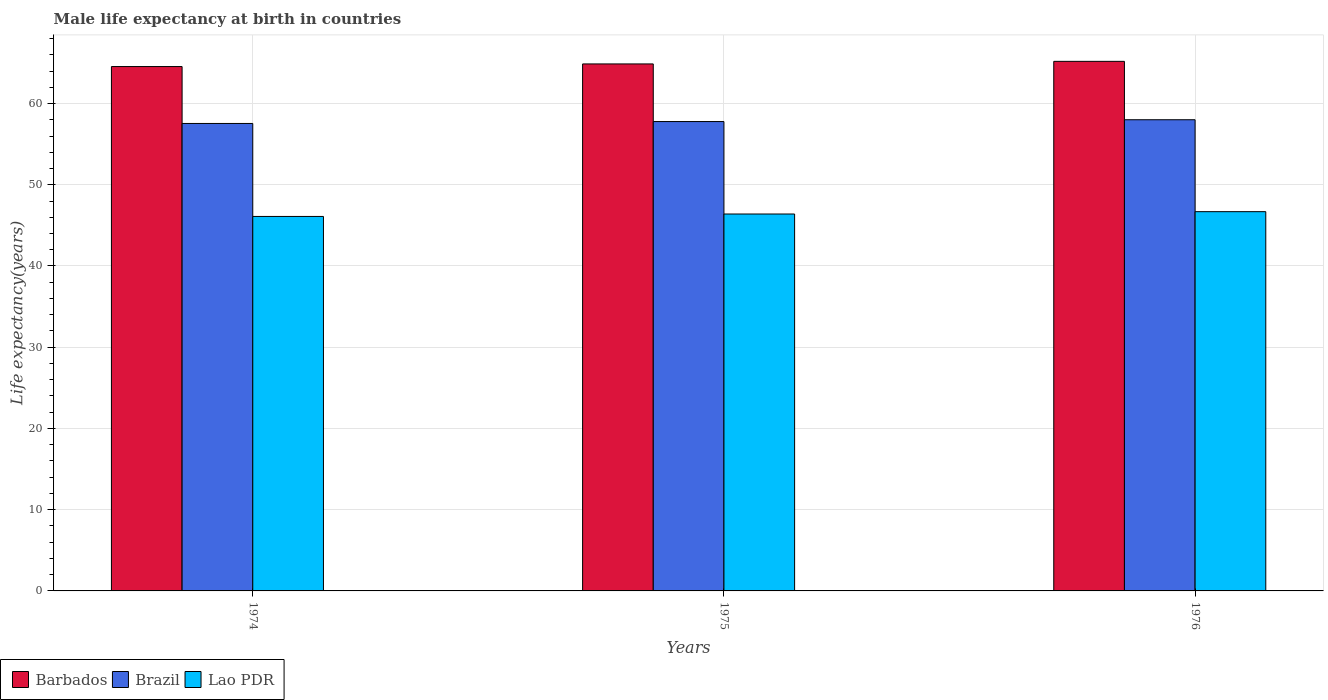How many different coloured bars are there?
Your answer should be compact. 3. How many groups of bars are there?
Make the answer very short. 3. Are the number of bars per tick equal to the number of legend labels?
Provide a short and direct response. Yes. Are the number of bars on each tick of the X-axis equal?
Offer a terse response. Yes. How many bars are there on the 2nd tick from the left?
Provide a short and direct response. 3. What is the label of the 1st group of bars from the left?
Offer a very short reply. 1974. In how many cases, is the number of bars for a given year not equal to the number of legend labels?
Keep it short and to the point. 0. What is the male life expectancy at birth in Barbados in 1974?
Keep it short and to the point. 64.55. Across all years, what is the maximum male life expectancy at birth in Brazil?
Give a very brief answer. 58. Across all years, what is the minimum male life expectancy at birth in Barbados?
Offer a very short reply. 64.55. In which year was the male life expectancy at birth in Lao PDR maximum?
Provide a succinct answer. 1976. In which year was the male life expectancy at birth in Lao PDR minimum?
Offer a terse response. 1974. What is the total male life expectancy at birth in Brazil in the graph?
Provide a short and direct response. 173.33. What is the difference between the male life expectancy at birth in Lao PDR in 1975 and that in 1976?
Offer a terse response. -0.29. What is the difference between the male life expectancy at birth in Brazil in 1975 and the male life expectancy at birth in Lao PDR in 1976?
Ensure brevity in your answer.  11.09. What is the average male life expectancy at birth in Lao PDR per year?
Provide a succinct answer. 46.4. In the year 1976, what is the difference between the male life expectancy at birth in Lao PDR and male life expectancy at birth in Barbados?
Keep it short and to the point. -18.5. What is the ratio of the male life expectancy at birth in Lao PDR in 1974 to that in 1976?
Your answer should be very brief. 0.99. Is the male life expectancy at birth in Brazil in 1975 less than that in 1976?
Provide a short and direct response. Yes. What is the difference between the highest and the second highest male life expectancy at birth in Lao PDR?
Your answer should be very brief. 0.29. What is the difference between the highest and the lowest male life expectancy at birth in Barbados?
Your answer should be compact. 0.64. What does the 1st bar from the left in 1975 represents?
Offer a terse response. Barbados. What does the 2nd bar from the right in 1975 represents?
Ensure brevity in your answer.  Brazil. How many bars are there?
Your answer should be compact. 9. Are all the bars in the graph horizontal?
Provide a succinct answer. No. How many years are there in the graph?
Your response must be concise. 3. Are the values on the major ticks of Y-axis written in scientific E-notation?
Provide a short and direct response. No. Does the graph contain any zero values?
Make the answer very short. No. Does the graph contain grids?
Ensure brevity in your answer.  Yes. How many legend labels are there?
Give a very brief answer. 3. What is the title of the graph?
Provide a short and direct response. Male life expectancy at birth in countries. What is the label or title of the Y-axis?
Ensure brevity in your answer.  Life expectancy(years). What is the Life expectancy(years) of Barbados in 1974?
Make the answer very short. 64.55. What is the Life expectancy(years) in Brazil in 1974?
Keep it short and to the point. 57.55. What is the Life expectancy(years) of Lao PDR in 1974?
Provide a succinct answer. 46.1. What is the Life expectancy(years) in Barbados in 1975?
Give a very brief answer. 64.87. What is the Life expectancy(years) in Brazil in 1975?
Give a very brief answer. 57.78. What is the Life expectancy(years) in Lao PDR in 1975?
Your answer should be compact. 46.4. What is the Life expectancy(years) in Barbados in 1976?
Your answer should be very brief. 65.19. What is the Life expectancy(years) of Brazil in 1976?
Your response must be concise. 58. What is the Life expectancy(years) of Lao PDR in 1976?
Offer a very short reply. 46.69. Across all years, what is the maximum Life expectancy(years) in Barbados?
Offer a very short reply. 65.19. Across all years, what is the maximum Life expectancy(years) in Brazil?
Your answer should be very brief. 58. Across all years, what is the maximum Life expectancy(years) of Lao PDR?
Provide a short and direct response. 46.69. Across all years, what is the minimum Life expectancy(years) of Barbados?
Offer a terse response. 64.55. Across all years, what is the minimum Life expectancy(years) of Brazil?
Keep it short and to the point. 57.55. Across all years, what is the minimum Life expectancy(years) of Lao PDR?
Your response must be concise. 46.1. What is the total Life expectancy(years) of Barbados in the graph?
Offer a very short reply. 194.61. What is the total Life expectancy(years) in Brazil in the graph?
Provide a short and direct response. 173.33. What is the total Life expectancy(years) in Lao PDR in the graph?
Offer a very short reply. 139.19. What is the difference between the Life expectancy(years) of Barbados in 1974 and that in 1975?
Your answer should be compact. -0.32. What is the difference between the Life expectancy(years) of Brazil in 1974 and that in 1975?
Your answer should be compact. -0.24. What is the difference between the Life expectancy(years) of Lao PDR in 1974 and that in 1975?
Make the answer very short. -0.3. What is the difference between the Life expectancy(years) of Barbados in 1974 and that in 1976?
Provide a short and direct response. -0.64. What is the difference between the Life expectancy(years) in Brazil in 1974 and that in 1976?
Your answer should be compact. -0.46. What is the difference between the Life expectancy(years) of Lao PDR in 1974 and that in 1976?
Give a very brief answer. -0.59. What is the difference between the Life expectancy(years) of Barbados in 1975 and that in 1976?
Provide a succinct answer. -0.32. What is the difference between the Life expectancy(years) in Brazil in 1975 and that in 1976?
Your answer should be compact. -0.22. What is the difference between the Life expectancy(years) of Lao PDR in 1975 and that in 1976?
Provide a short and direct response. -0.29. What is the difference between the Life expectancy(years) of Barbados in 1974 and the Life expectancy(years) of Brazil in 1975?
Give a very brief answer. 6.77. What is the difference between the Life expectancy(years) in Barbados in 1974 and the Life expectancy(years) in Lao PDR in 1975?
Keep it short and to the point. 18.15. What is the difference between the Life expectancy(years) of Brazil in 1974 and the Life expectancy(years) of Lao PDR in 1975?
Give a very brief answer. 11.15. What is the difference between the Life expectancy(years) of Barbados in 1974 and the Life expectancy(years) of Brazil in 1976?
Provide a short and direct response. 6.55. What is the difference between the Life expectancy(years) of Barbados in 1974 and the Life expectancy(years) of Lao PDR in 1976?
Offer a very short reply. 17.86. What is the difference between the Life expectancy(years) in Brazil in 1974 and the Life expectancy(years) in Lao PDR in 1976?
Your answer should be compact. 10.86. What is the difference between the Life expectancy(years) of Barbados in 1975 and the Life expectancy(years) of Brazil in 1976?
Your response must be concise. 6.87. What is the difference between the Life expectancy(years) of Barbados in 1975 and the Life expectancy(years) of Lao PDR in 1976?
Offer a very short reply. 18.19. What is the difference between the Life expectancy(years) of Brazil in 1975 and the Life expectancy(years) of Lao PDR in 1976?
Make the answer very short. 11.09. What is the average Life expectancy(years) in Barbados per year?
Offer a terse response. 64.87. What is the average Life expectancy(years) in Brazil per year?
Give a very brief answer. 57.78. What is the average Life expectancy(years) of Lao PDR per year?
Ensure brevity in your answer.  46.4. In the year 1974, what is the difference between the Life expectancy(years) of Barbados and Life expectancy(years) of Brazil?
Ensure brevity in your answer.  7. In the year 1974, what is the difference between the Life expectancy(years) of Barbados and Life expectancy(years) of Lao PDR?
Your answer should be very brief. 18.45. In the year 1974, what is the difference between the Life expectancy(years) of Brazil and Life expectancy(years) of Lao PDR?
Your answer should be very brief. 11.45. In the year 1975, what is the difference between the Life expectancy(years) of Barbados and Life expectancy(years) of Brazil?
Your response must be concise. 7.09. In the year 1975, what is the difference between the Life expectancy(years) in Barbados and Life expectancy(years) in Lao PDR?
Keep it short and to the point. 18.47. In the year 1975, what is the difference between the Life expectancy(years) in Brazil and Life expectancy(years) in Lao PDR?
Your answer should be very brief. 11.38. In the year 1976, what is the difference between the Life expectancy(years) of Barbados and Life expectancy(years) of Brazil?
Your answer should be compact. 7.19. In the year 1976, what is the difference between the Life expectancy(years) of Barbados and Life expectancy(years) of Lao PDR?
Offer a very short reply. 18.5. In the year 1976, what is the difference between the Life expectancy(years) in Brazil and Life expectancy(years) in Lao PDR?
Your response must be concise. 11.32. What is the ratio of the Life expectancy(years) in Barbados in 1974 to that in 1975?
Provide a short and direct response. 0.99. What is the ratio of the Life expectancy(years) of Brazil in 1974 to that in 1975?
Your response must be concise. 1. What is the ratio of the Life expectancy(years) of Barbados in 1974 to that in 1976?
Your response must be concise. 0.99. What is the ratio of the Life expectancy(years) in Lao PDR in 1974 to that in 1976?
Ensure brevity in your answer.  0.99. What is the ratio of the Life expectancy(years) of Barbados in 1975 to that in 1976?
Give a very brief answer. 1. What is the ratio of the Life expectancy(years) of Brazil in 1975 to that in 1976?
Your response must be concise. 1. What is the difference between the highest and the second highest Life expectancy(years) of Barbados?
Your answer should be very brief. 0.32. What is the difference between the highest and the second highest Life expectancy(years) in Brazil?
Offer a terse response. 0.22. What is the difference between the highest and the second highest Life expectancy(years) in Lao PDR?
Provide a succinct answer. 0.29. What is the difference between the highest and the lowest Life expectancy(years) of Barbados?
Provide a short and direct response. 0.64. What is the difference between the highest and the lowest Life expectancy(years) of Brazil?
Provide a succinct answer. 0.46. What is the difference between the highest and the lowest Life expectancy(years) in Lao PDR?
Ensure brevity in your answer.  0.59. 